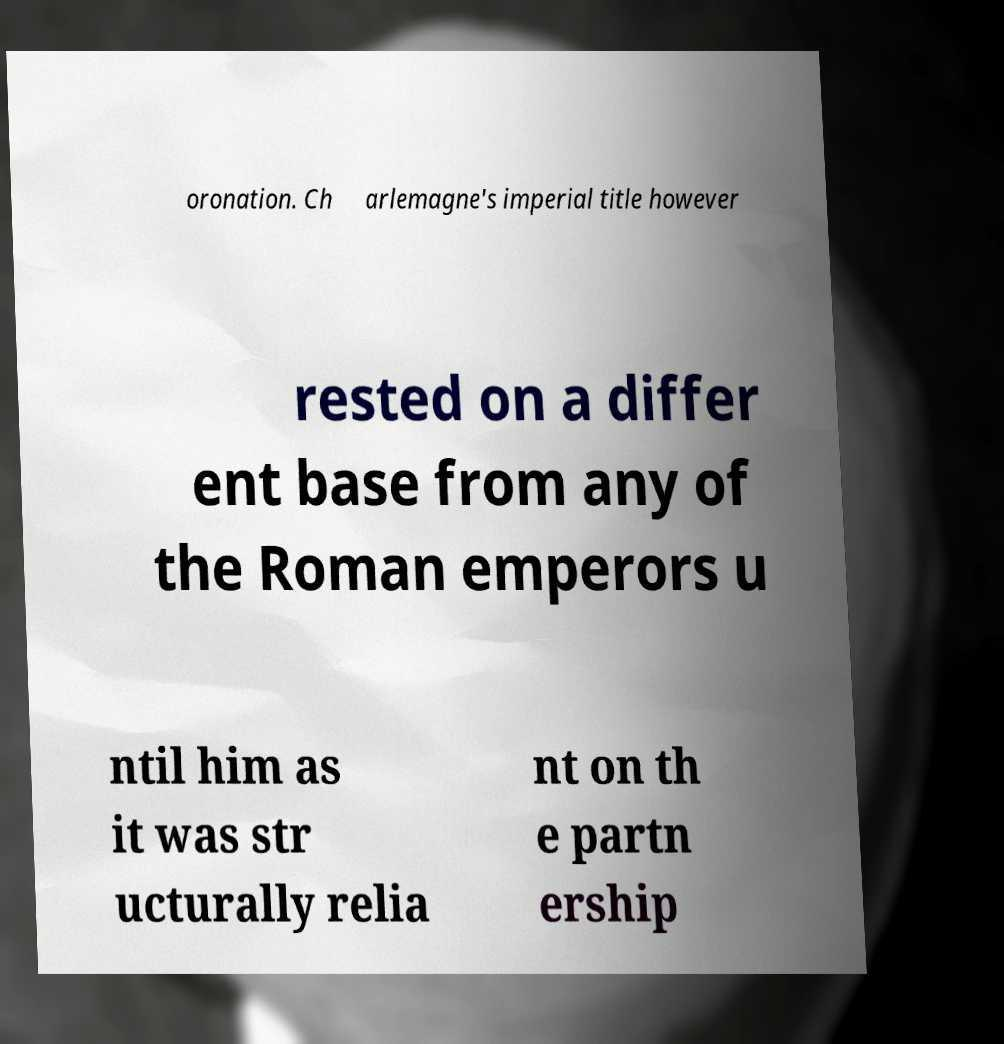What messages or text are displayed in this image? I need them in a readable, typed format. oronation. Ch arlemagne's imperial title however rested on a differ ent base from any of the Roman emperors u ntil him as it was str ucturally relia nt on th e partn ership 